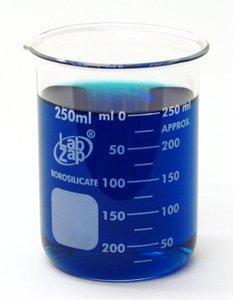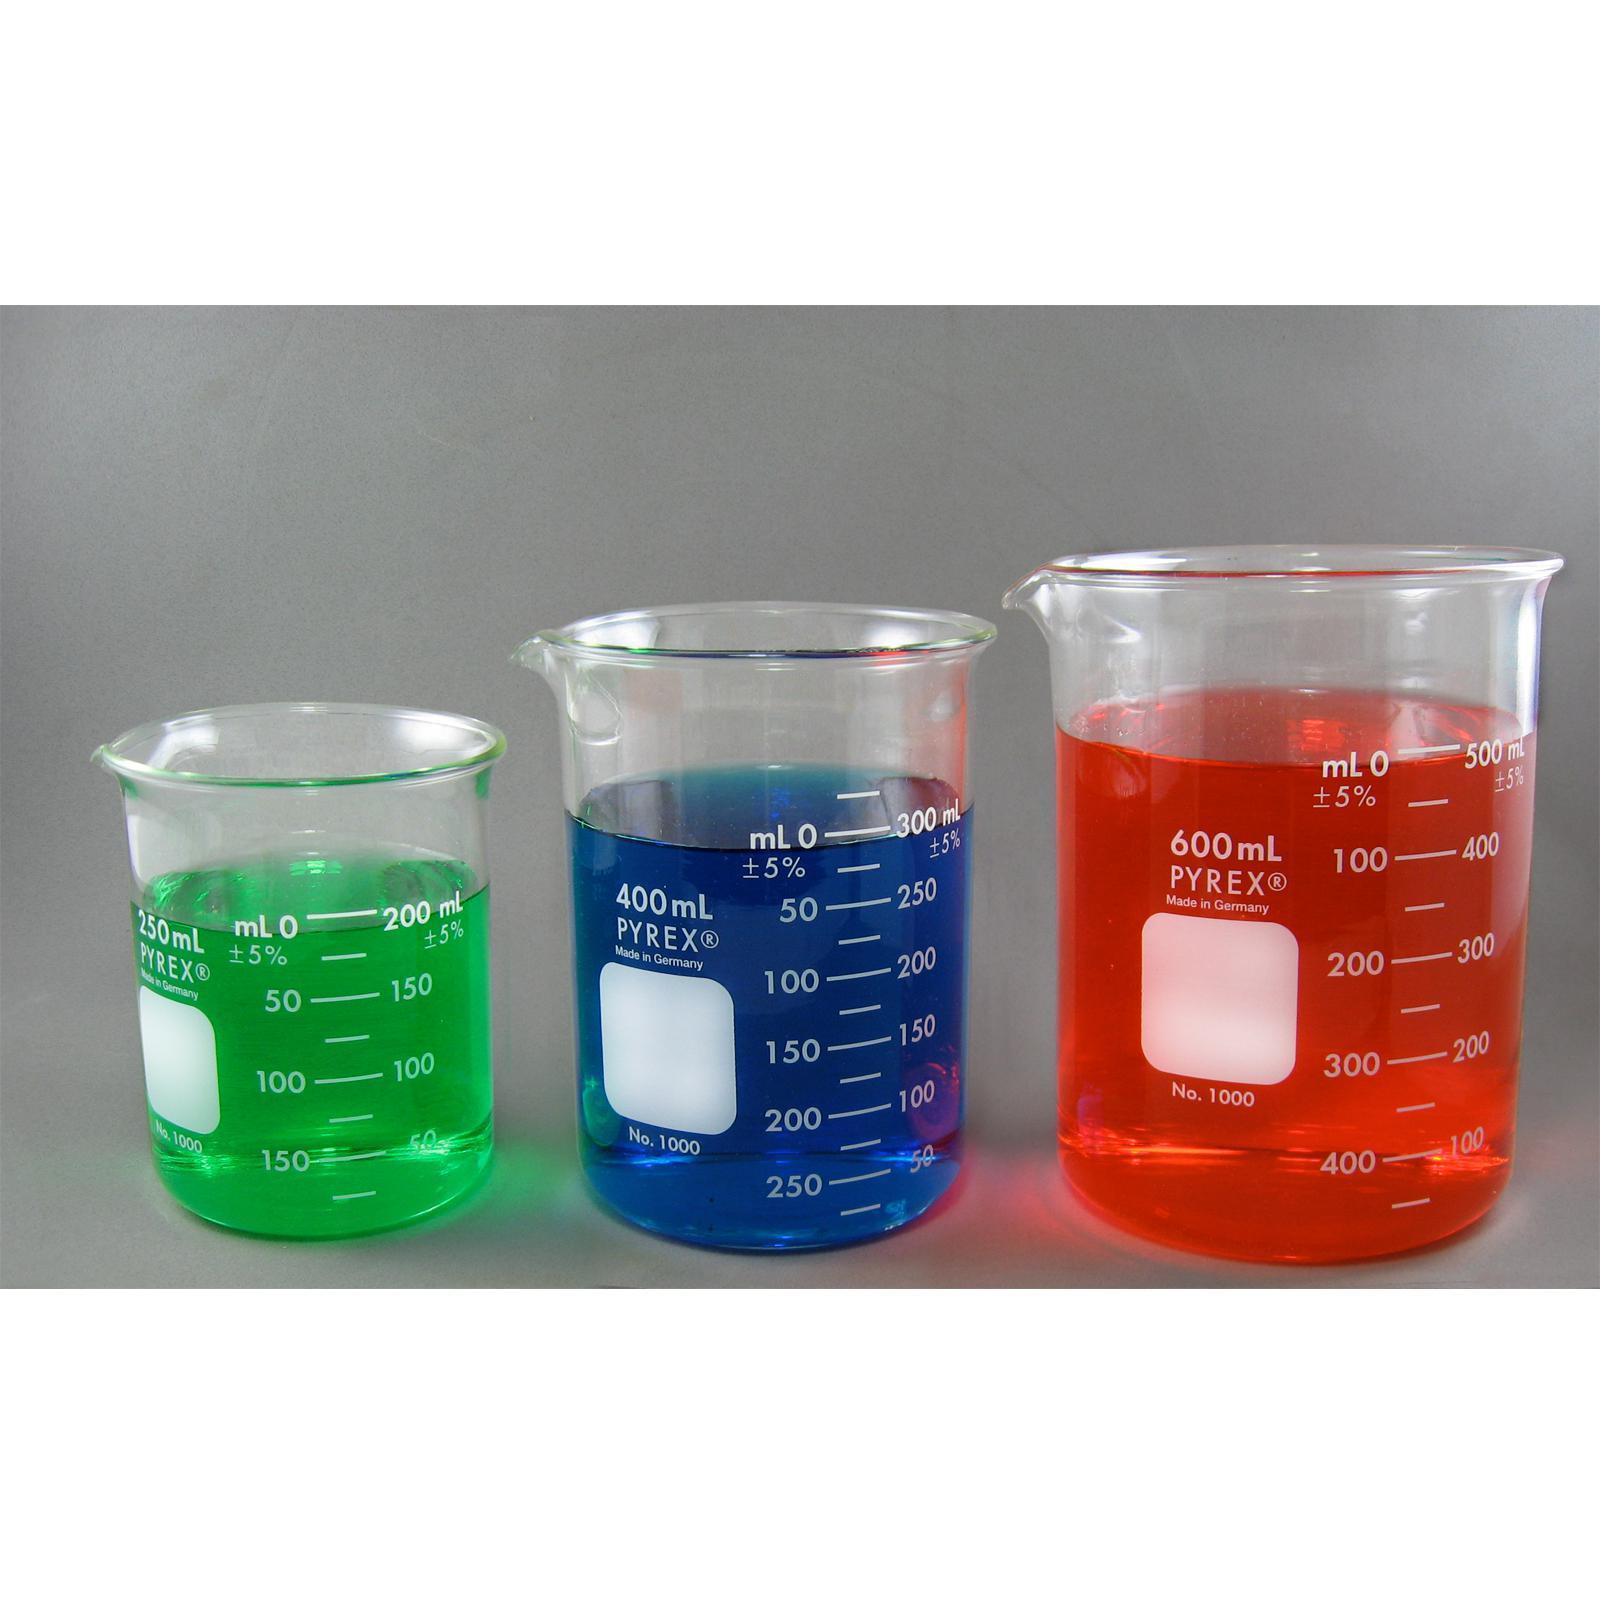The first image is the image on the left, the second image is the image on the right. For the images displayed, is the sentence "there is red liquid in a glass beaker" factually correct? Answer yes or no. Yes. The first image is the image on the left, the second image is the image on the right. Considering the images on both sides, is "There is no less than one clear beaker with red liquid in it" valid? Answer yes or no. Yes. 